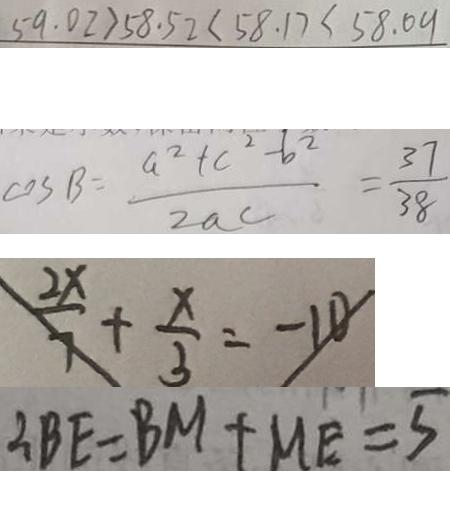Convert formula to latex. <formula><loc_0><loc_0><loc_500><loc_500>5 9 . 0 2 > 5 8 . 5 2 < 5 8 . 1 7 < 5 8 . 0 9 
 \cos B = \frac { a ^ { 2 } + c ^ { 2 } - b ^ { 2 } } { 2 a c } = \frac { 3 7 } { 3 8 } 
 \frac { 2 x } { 7 } + \frac { x } { 3 } = - 1 0 
 \therefore B E = B M + M E = 5</formula> 